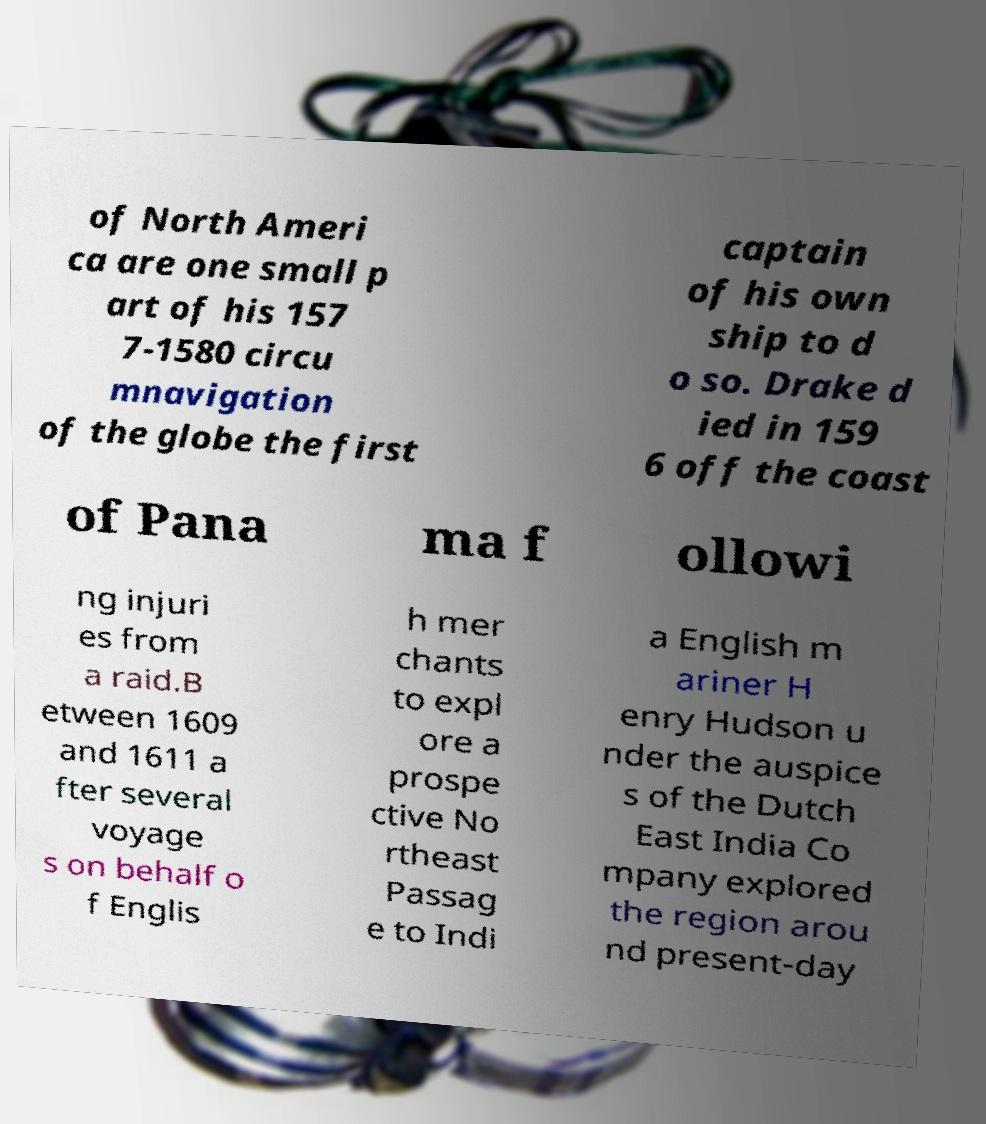Can you read and provide the text displayed in the image?This photo seems to have some interesting text. Can you extract and type it out for me? of North Ameri ca are one small p art of his 157 7-1580 circu mnavigation of the globe the first captain of his own ship to d o so. Drake d ied in 159 6 off the coast of Pana ma f ollowi ng injuri es from a raid.B etween 1609 and 1611 a fter several voyage s on behalf o f Englis h mer chants to expl ore a prospe ctive No rtheast Passag e to Indi a English m ariner H enry Hudson u nder the auspice s of the Dutch East India Co mpany explored the region arou nd present-day 